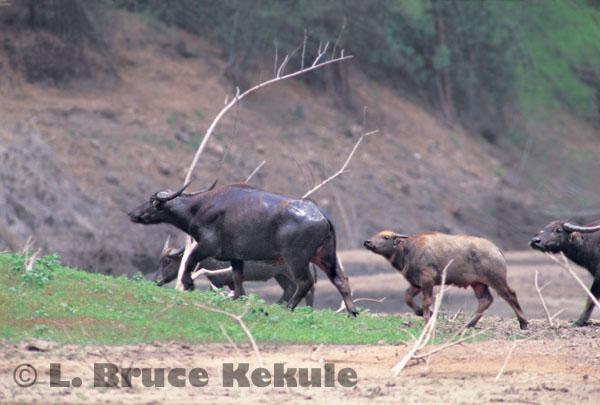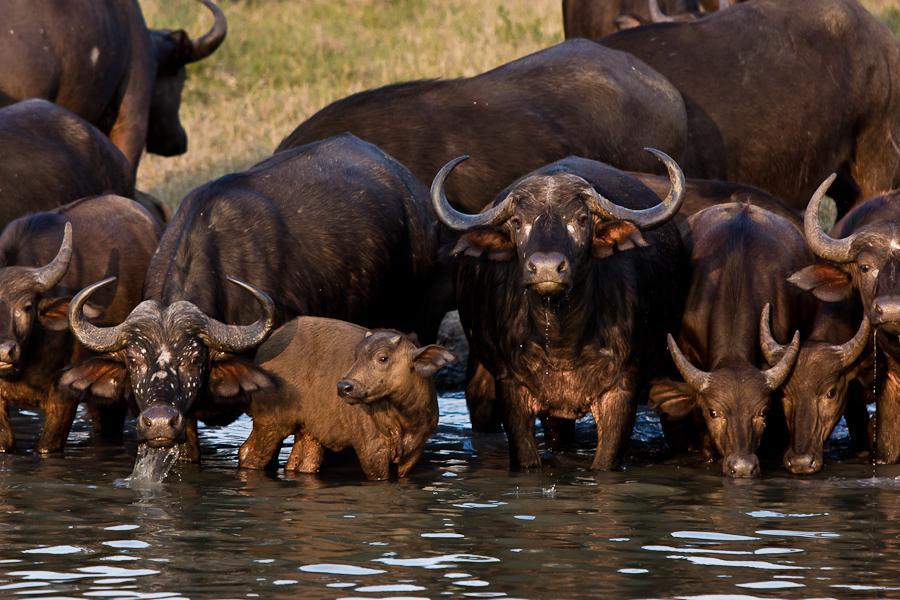The first image is the image on the left, the second image is the image on the right. For the images displayed, is the sentence "there are animals in the water in the image on the right side" factually correct? Answer yes or no. Yes. The first image is the image on the left, the second image is the image on the right. For the images displayed, is the sentence "All animals in the right image are on land." factually correct? Answer yes or no. No. 